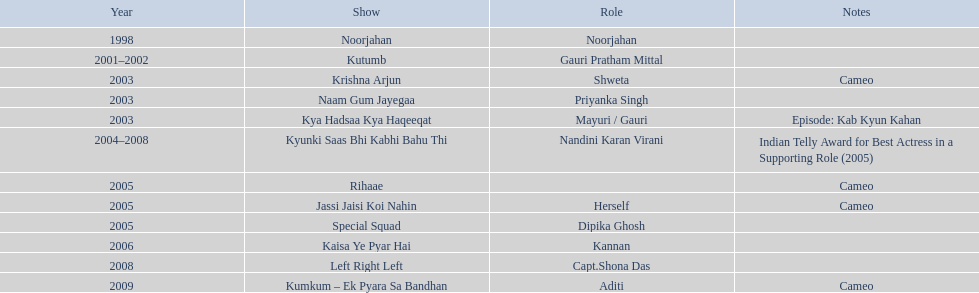Can you give me this table as a dict? {'header': ['Year', 'Show', 'Role', 'Notes'], 'rows': [['1998', 'Noorjahan', 'Noorjahan', ''], ['2001–2002', 'Kutumb', 'Gauri Pratham Mittal', ''], ['2003', 'Krishna Arjun', 'Shweta', 'Cameo'], ['2003', 'Naam Gum Jayegaa', 'Priyanka Singh', ''], ['2003', 'Kya Hadsaa Kya Haqeeqat', 'Mayuri / Gauri', 'Episode: Kab Kyun Kahan'], ['2004–2008', 'Kyunki Saas Bhi Kabhi Bahu Thi', 'Nandini Karan Virani', 'Indian Telly Award for Best Actress in a Supporting Role (2005)'], ['2005', 'Rihaae', '', 'Cameo'], ['2005', 'Jassi Jaisi Koi Nahin', 'Herself', 'Cameo'], ['2005', 'Special Squad', 'Dipika Ghosh', ''], ['2006', 'Kaisa Ye Pyar Hai', 'Kannan', ''], ['2008', 'Left Right Left', 'Capt.Shona Das', ''], ['2009', 'Kumkum – Ek Pyara Sa Bandhan', 'Aditi', 'Cameo']]} How many shows exist in total? Noorjahan, Kutumb, Krishna Arjun, Naam Gum Jayegaa, Kya Hadsaa Kya Haqeeqat, Kyunki Saas Bhi Kabhi Bahu Thi, Rihaae, Jassi Jaisi Koi Nahin, Special Squad, Kaisa Ye Pyar Hai, Left Right Left, Kumkum – Ek Pyara Sa Bandhan. In how many of them did she appear in a cameo? Krishna Arjun, Rihaae, Jassi Jaisi Koi Nahin, Kumkum – Ek Pyara Sa Bandhan. Among those, in how many instances did she represent herself? Jassi Jaisi Koi Nahin. 